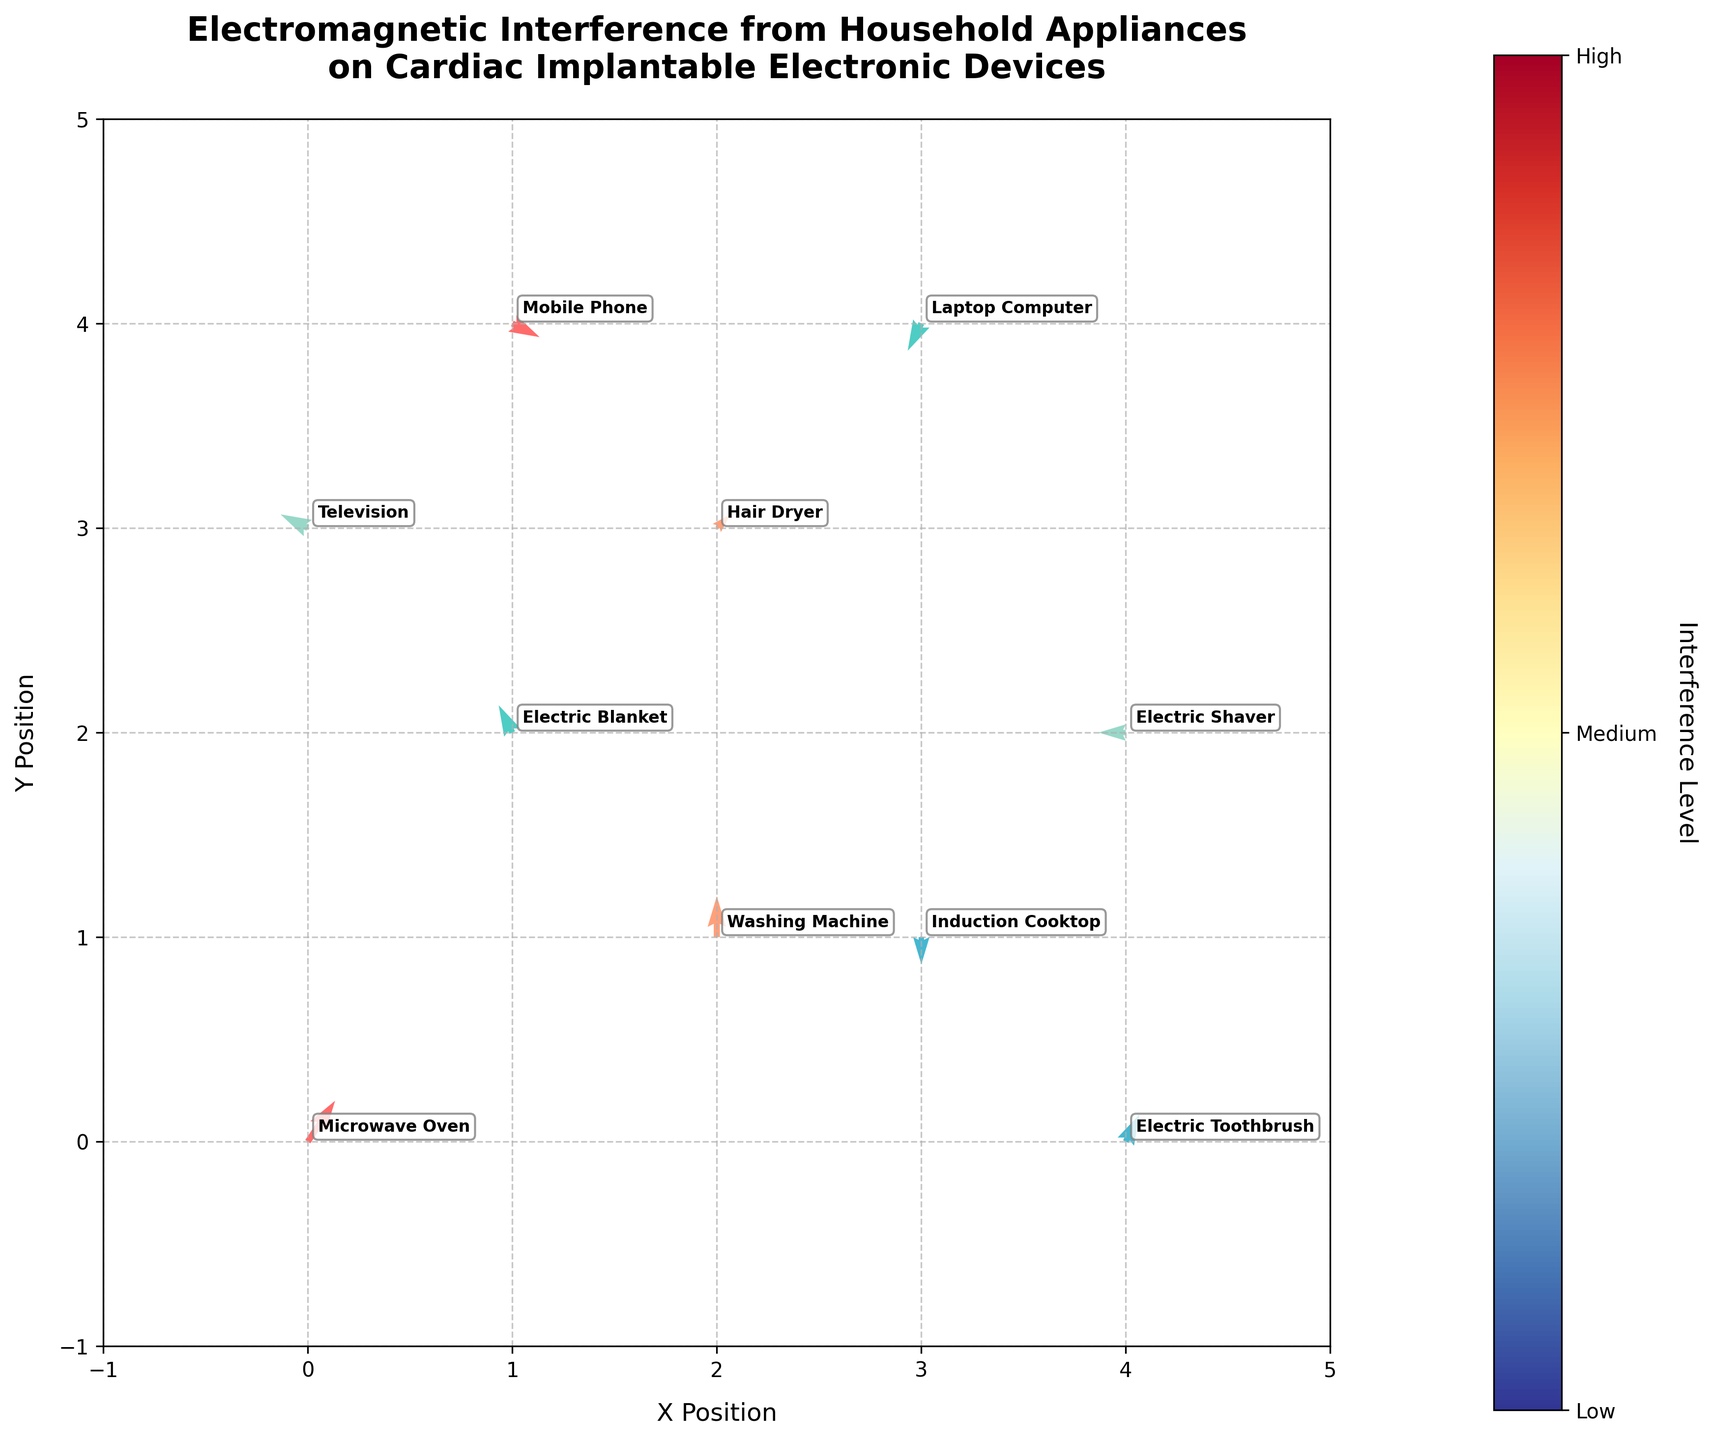What's the title of the plot? The title is written at the top of the figure.
Answer: Electromagnetic Interference from Household Appliances on Cardiac Implantable Electronic Devices What do the colors of the quivers represent? The colorbar on the right side of the figure, with labels 'Low,' 'Medium,' and 'High,' represents different levels of interference from household appliances.
Answer: Levels of interference Which appliance has the highest level of interference? The highest level of interference is indicated by the color that corresponds to 'High' on the colorbar. The appliances in this color are identified.
Answer: Microwave Oven and Mobile Phone How many appliances have a 'Medium' interference level? Identify the colors representing the 'Medium' level on the figure and count the number of quivers in that color.
Answer: Three appliances What is the direction and magnitude of the quiver for the Washing Machine? The direction and magnitude can be understood by looking at the arrow associated with the Washing Machine. The quiver points upwards and has coordinates (2, 1) indicating a magnitude of (0, 3).
Answer: Upwards, magnitude (0, 3) Which appliance has a quiver pointing downwards and what is its interference level? By scanning the plot, the appliance with a quiver pointing downwards is identified, noting its associated interference color.
Answer: Induction Cooktop, Low Compare the interference level between the Electric Blanket and Hair Dryer. Which one is higher? Locate the Electric Blanket and Hair Dryer on the plot, observe their colors, and refer to the colorbar to determine the interference levels.
Answer: Hair Dryer What is the total number of appliances plotted? Count all the labeled appliances on the plot.
Answer: Ten appliances How does the interference level of the Television compare to that of the Mobile Phone? Identify the position and color associated with each appliance and refer to the colorbar for their respective interference levels.
Answer: Mobile Phone has a higher interference level Does any quiver have no X-component? If so, which appliance does it represent? Observe all quivers to determine if any have no horizontal (X) component. The quiver pointing straight up or down will have no X-component.
Answer: Induction Cooktop and Washing Machine 